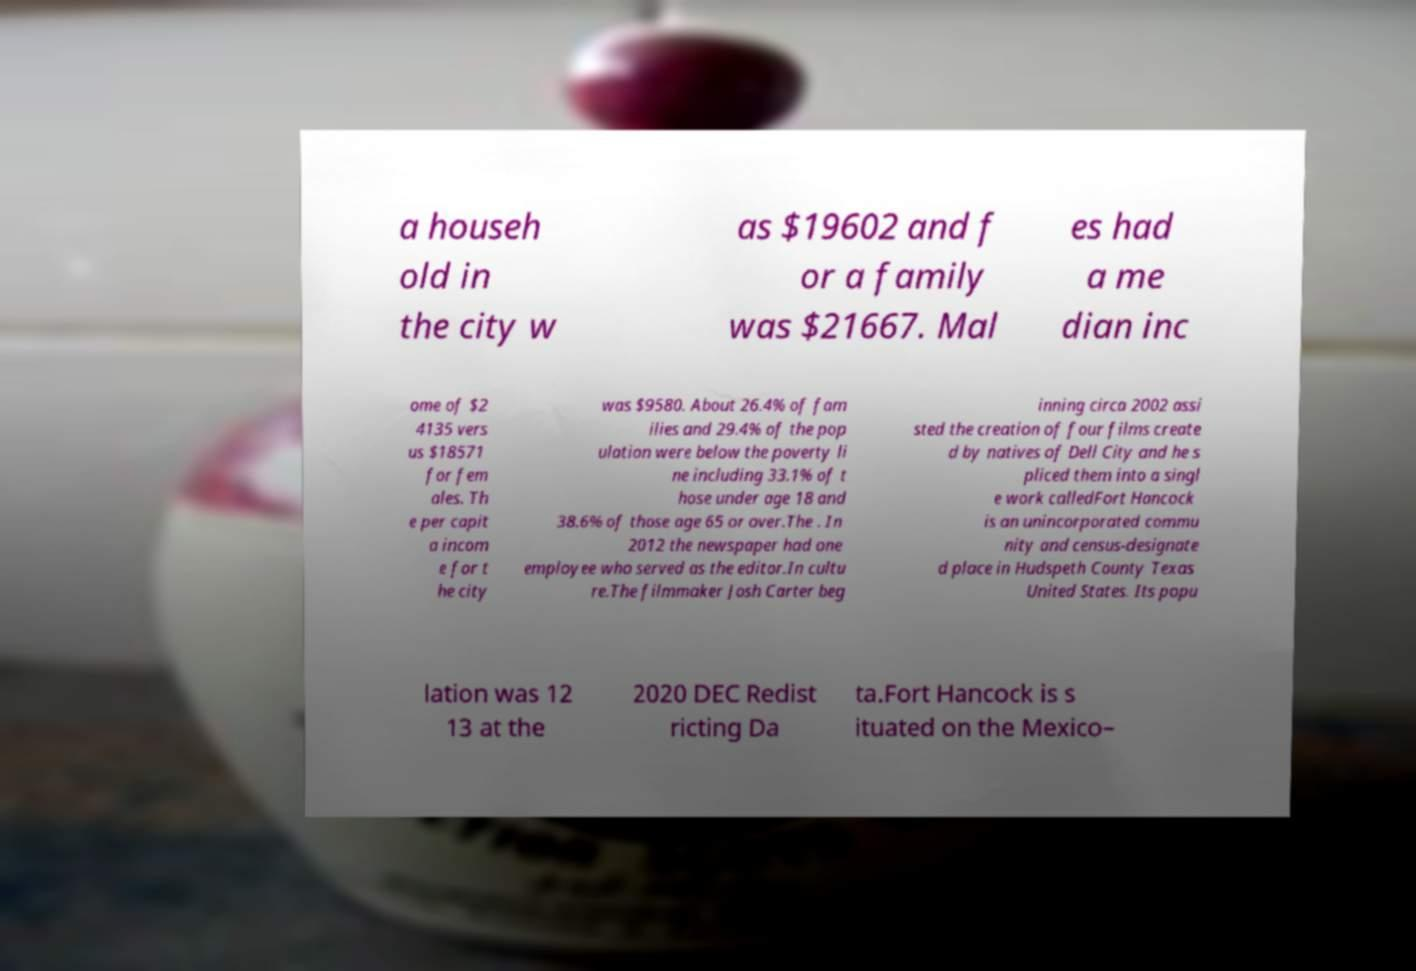Can you read and provide the text displayed in the image?This photo seems to have some interesting text. Can you extract and type it out for me? a househ old in the city w as $19602 and f or a family was $21667. Mal es had a me dian inc ome of $2 4135 vers us $18571 for fem ales. Th e per capit a incom e for t he city was $9580. About 26.4% of fam ilies and 29.4% of the pop ulation were below the poverty li ne including 33.1% of t hose under age 18 and 38.6% of those age 65 or over.The . In 2012 the newspaper had one employee who served as the editor.In cultu re.The filmmaker Josh Carter beg inning circa 2002 assi sted the creation of four films create d by natives of Dell City and he s pliced them into a singl e work calledFort Hancock is an unincorporated commu nity and census-designate d place in Hudspeth County Texas United States. Its popu lation was 12 13 at the 2020 DEC Redist ricting Da ta.Fort Hancock is s ituated on the Mexico– 